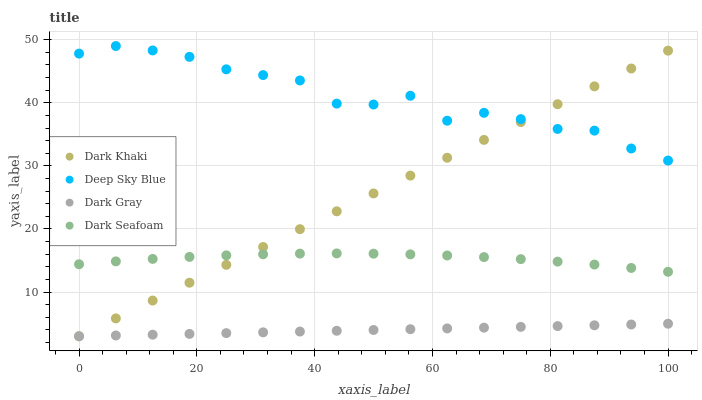Does Dark Gray have the minimum area under the curve?
Answer yes or no. Yes. Does Deep Sky Blue have the maximum area under the curve?
Answer yes or no. Yes. Does Dark Seafoam have the minimum area under the curve?
Answer yes or no. No. Does Dark Seafoam have the maximum area under the curve?
Answer yes or no. No. Is Dark Gray the smoothest?
Answer yes or no. Yes. Is Deep Sky Blue the roughest?
Answer yes or no. Yes. Is Dark Seafoam the smoothest?
Answer yes or no. No. Is Dark Seafoam the roughest?
Answer yes or no. No. Does Dark Khaki have the lowest value?
Answer yes or no. Yes. Does Dark Seafoam have the lowest value?
Answer yes or no. No. Does Deep Sky Blue have the highest value?
Answer yes or no. Yes. Does Dark Seafoam have the highest value?
Answer yes or no. No. Is Dark Seafoam less than Deep Sky Blue?
Answer yes or no. Yes. Is Deep Sky Blue greater than Dark Seafoam?
Answer yes or no. Yes. Does Dark Gray intersect Dark Khaki?
Answer yes or no. Yes. Is Dark Gray less than Dark Khaki?
Answer yes or no. No. Is Dark Gray greater than Dark Khaki?
Answer yes or no. No. Does Dark Seafoam intersect Deep Sky Blue?
Answer yes or no. No. 